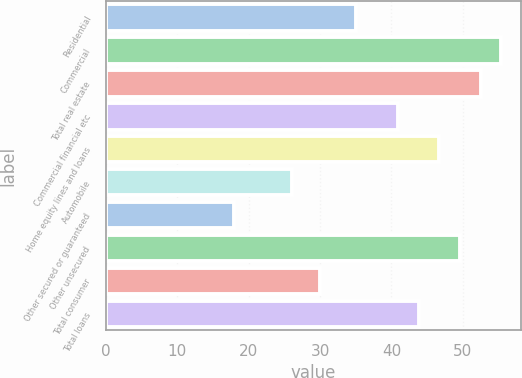Convert chart to OTSL. <chart><loc_0><loc_0><loc_500><loc_500><bar_chart><fcel>Residential<fcel>Commercial<fcel>Total real estate<fcel>Commercial financial etc<fcel>Home equity lines and loans<fcel>Automobile<fcel>Other secured or guaranteed<fcel>Other unsecured<fcel>Total consumer<fcel>Total loans<nl><fcel>35<fcel>55.4<fcel>52.5<fcel>40.9<fcel>46.7<fcel>26<fcel>18<fcel>49.6<fcel>30<fcel>43.8<nl></chart> 